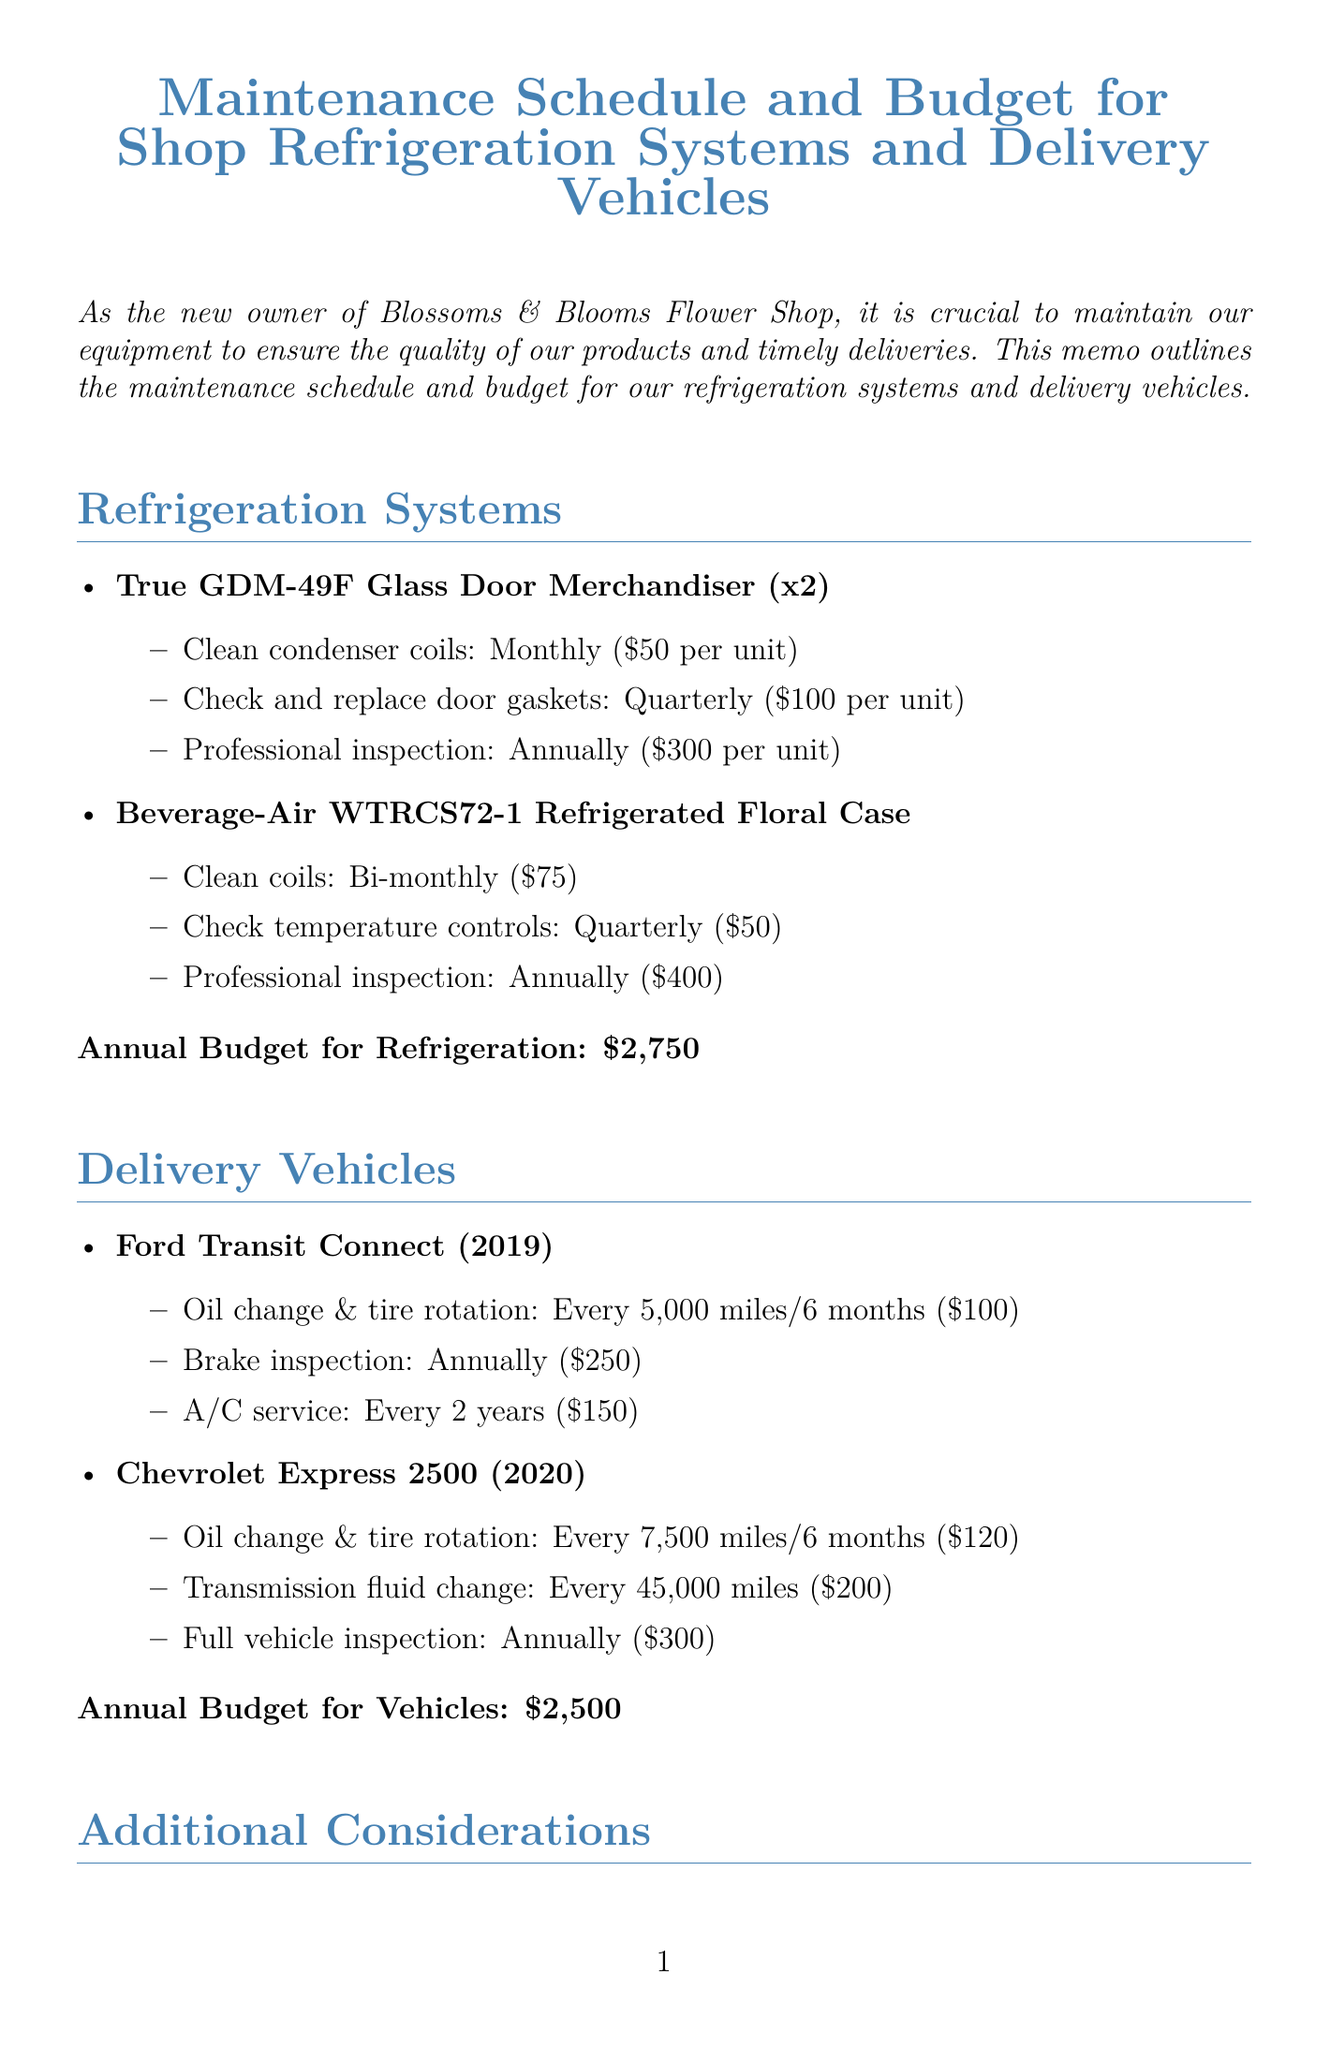What is the title of the memo? The title outlines the main subject of the memo, which is about maintenance schedules and budgets.
Answer: Maintenance Schedule and Budget for Shop Refrigeration Systems and Delivery Vehicles How many True GDM-49F Glass Door Merchandisers are there? The quantity specified for this equipment is crucial for understanding maintenance needs.
Answer: 2 What is the estimated cost for a professional inspection of the Beverage-Air WTRCS72-1 Refrigerated Floral Case? The memo provides specific costs for each maintenance task, allowing for budget planning.
Answer: $400 What is the annual budget allocated for refrigeration systems? This figure is important for financial planning for maintenance operations in the shop.
Answer: $2,750 How often should the oil change and tire rotation be performed for the Ford Transit Connect? The frequency of this maintenance task is important for vehicle upkeep and longevity.
Answer: Every 5,000 miles or 6 months What is the total annual budget for maintenance? This is the sum of the budgets for refrigeration systems and delivery vehicles.
Answer: $5,250 What additional consideration suggests training staff? This idea can help prevent improper maintenance and reduce costs effectively.
Answer: Train staff on basic maintenance procedures What type of vehicles are specified in the memo? Understanding the vehicles involved aids in appreciating their maintenance needs.
Answer: Delivery vehicles 